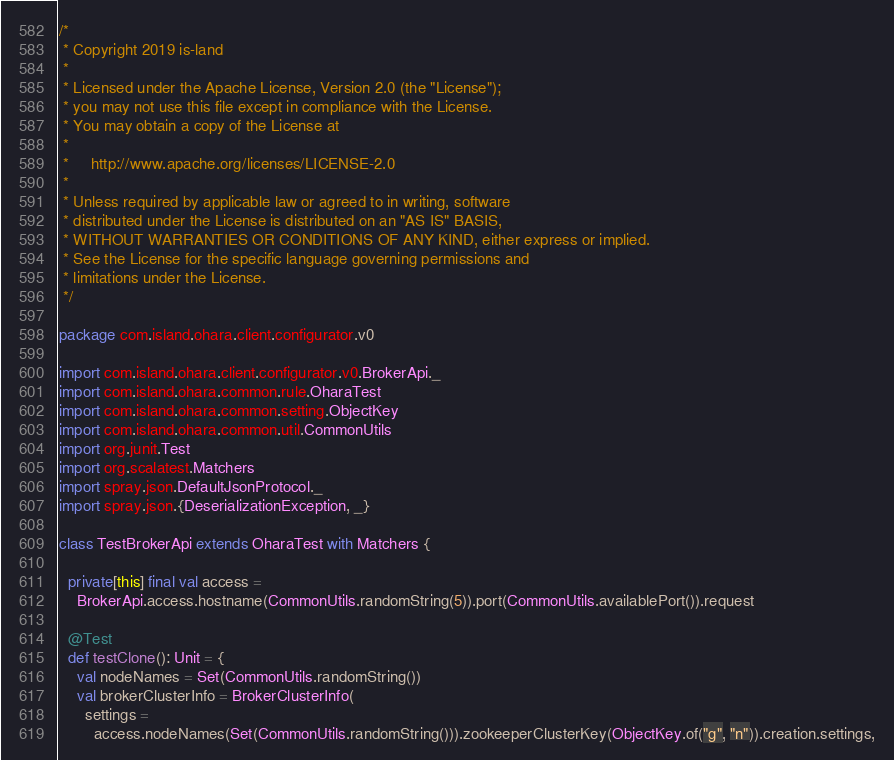<code> <loc_0><loc_0><loc_500><loc_500><_Scala_>/*
 * Copyright 2019 is-land
 *
 * Licensed under the Apache License, Version 2.0 (the "License");
 * you may not use this file except in compliance with the License.
 * You may obtain a copy of the License at
 *
 *     http://www.apache.org/licenses/LICENSE-2.0
 *
 * Unless required by applicable law or agreed to in writing, software
 * distributed under the License is distributed on an "AS IS" BASIS,
 * WITHOUT WARRANTIES OR CONDITIONS OF ANY KIND, either express or implied.
 * See the License for the specific language governing permissions and
 * limitations under the License.
 */

package com.island.ohara.client.configurator.v0

import com.island.ohara.client.configurator.v0.BrokerApi._
import com.island.ohara.common.rule.OharaTest
import com.island.ohara.common.setting.ObjectKey
import com.island.ohara.common.util.CommonUtils
import org.junit.Test
import org.scalatest.Matchers
import spray.json.DefaultJsonProtocol._
import spray.json.{DeserializationException, _}

class TestBrokerApi extends OharaTest with Matchers {

  private[this] final val access =
    BrokerApi.access.hostname(CommonUtils.randomString(5)).port(CommonUtils.availablePort()).request

  @Test
  def testClone(): Unit = {
    val nodeNames = Set(CommonUtils.randomString())
    val brokerClusterInfo = BrokerClusterInfo(
      settings =
        access.nodeNames(Set(CommonUtils.randomString())).zookeeperClusterKey(ObjectKey.of("g", "n")).creation.settings,</code> 